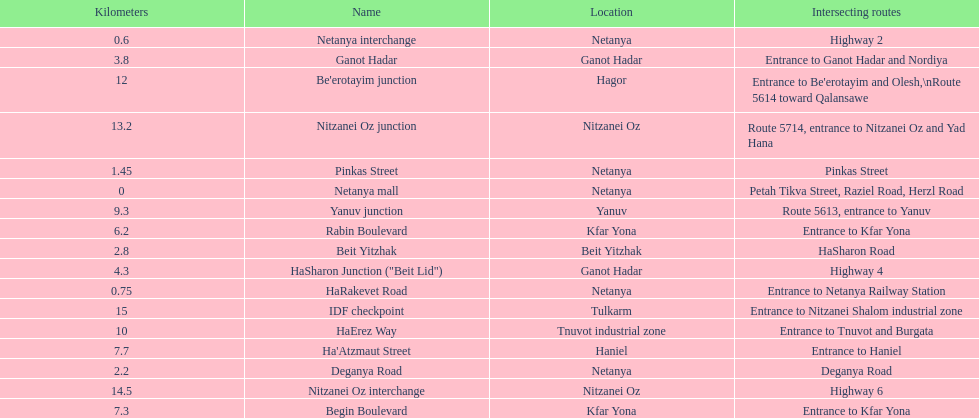How many locations in netanya are there? 5. 